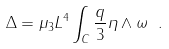<formula> <loc_0><loc_0><loc_500><loc_500>\Delta = \mu _ { 3 } L ^ { 4 } \int _ { C } \frac { q } { 3 } \eta \wedge \omega \ .</formula> 